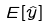Convert formula to latex. <formula><loc_0><loc_0><loc_500><loc_500>E [ \hat { y } ]</formula> 